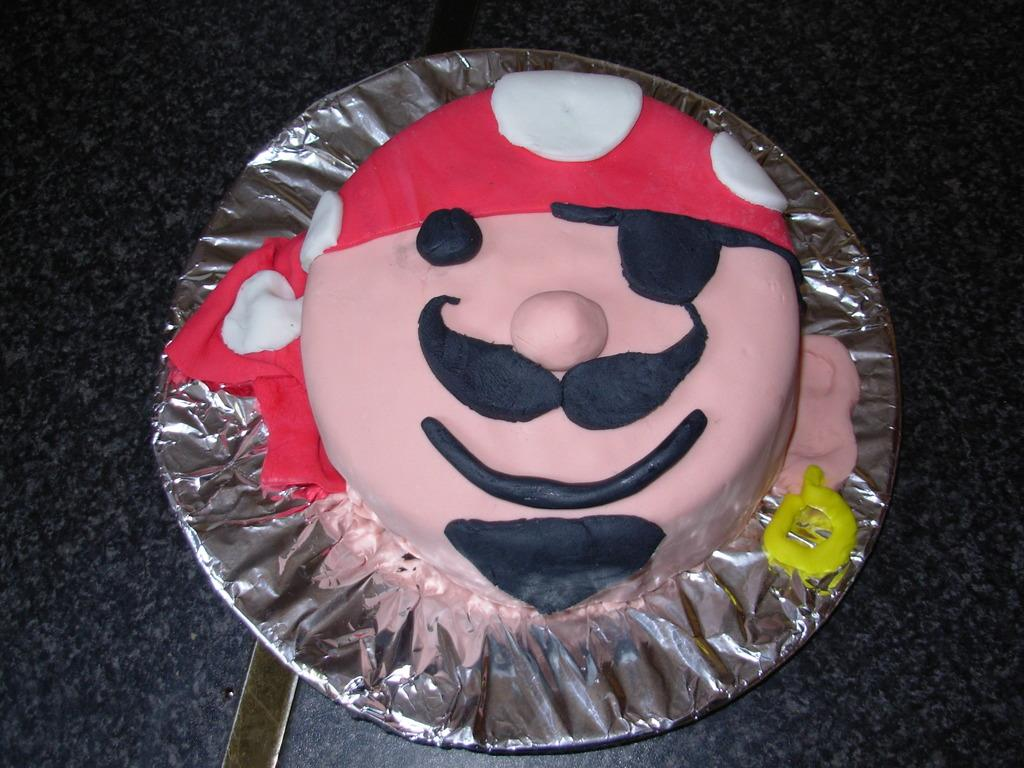What is the main subject of the image? There is a cake in the image. How is the cake positioned in the image? The cake is placed on a plate. What type of material is visible in the image? There is a silver foil paper in the image. Where might the image have been taken? The image appears to be taken on a table. What nation is represented by the cake in the image? The image does not depict any specific nation, as it only shows a cake on a plate with silver foil paper. Can you provide a detailed description of the cake's decorations? The provided facts do not include any information about the cake's decorations, so it is impossible to provide a detailed description. 